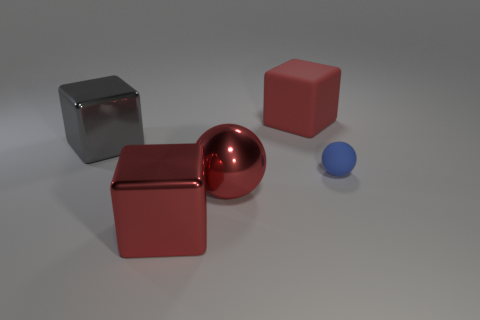There is a metallic thing that is the same color as the big metallic ball; what shape is it?
Your response must be concise. Cube. There is a red block in front of the blue rubber ball; what size is it?
Provide a short and direct response. Large. Do the ball to the left of the red rubber cube and the ball right of the red matte block have the same size?
Offer a very short reply. No. How many red blocks are made of the same material as the big gray thing?
Your answer should be very brief. 1. The large ball is what color?
Offer a very short reply. Red. Are there any large red blocks on the left side of the big red ball?
Offer a very short reply. Yes. Is the big metal sphere the same color as the matte block?
Your answer should be very brief. Yes. How many rubber spheres are the same color as the small matte thing?
Make the answer very short. 0. What is the size of the cube that is on the right side of the metal block that is in front of the blue sphere?
Make the answer very short. Large. The blue matte thing is what shape?
Offer a very short reply. Sphere. 